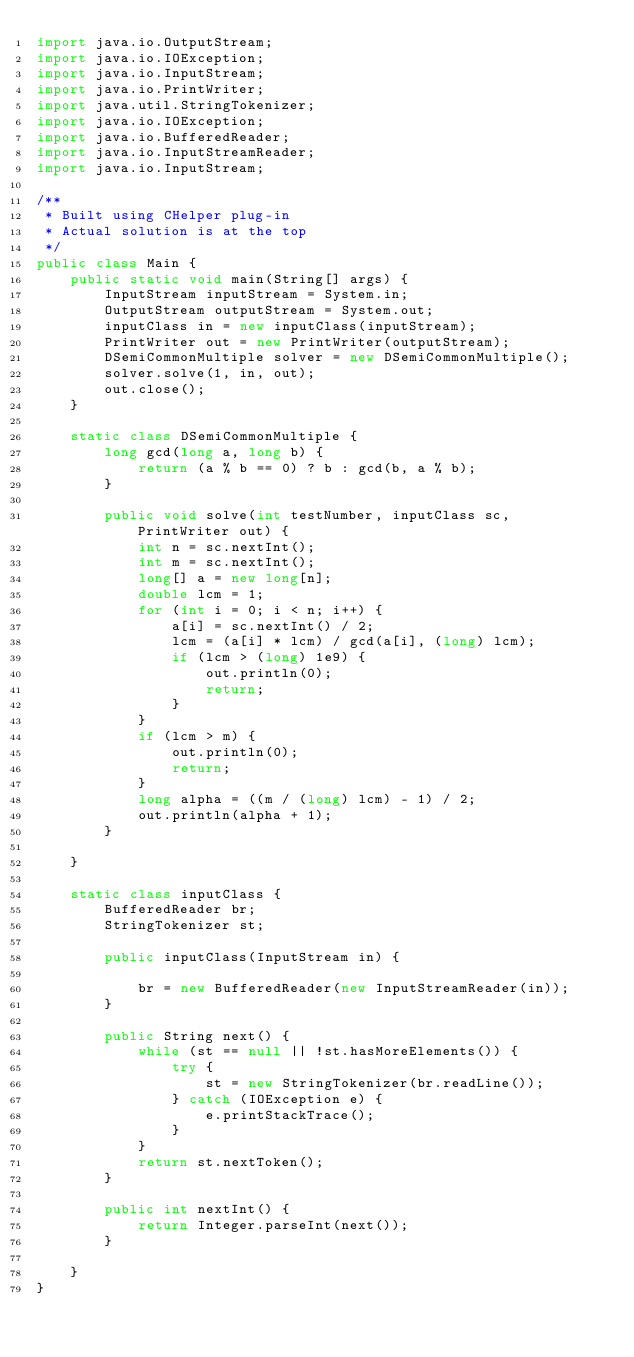<code> <loc_0><loc_0><loc_500><loc_500><_Java_>import java.io.OutputStream;
import java.io.IOException;
import java.io.InputStream;
import java.io.PrintWriter;
import java.util.StringTokenizer;
import java.io.IOException;
import java.io.BufferedReader;
import java.io.InputStreamReader;
import java.io.InputStream;

/**
 * Built using CHelper plug-in
 * Actual solution is at the top
 */
public class Main {
    public static void main(String[] args) {
        InputStream inputStream = System.in;
        OutputStream outputStream = System.out;
        inputClass in = new inputClass(inputStream);
        PrintWriter out = new PrintWriter(outputStream);
        DSemiCommonMultiple solver = new DSemiCommonMultiple();
        solver.solve(1, in, out);
        out.close();
    }

    static class DSemiCommonMultiple {
        long gcd(long a, long b) {
            return (a % b == 0) ? b : gcd(b, a % b);
        }

        public void solve(int testNumber, inputClass sc, PrintWriter out) {
            int n = sc.nextInt();
            int m = sc.nextInt();
            long[] a = new long[n];
            double lcm = 1;
            for (int i = 0; i < n; i++) {
                a[i] = sc.nextInt() / 2;
                lcm = (a[i] * lcm) / gcd(a[i], (long) lcm);
                if (lcm > (long) 1e9) {
                    out.println(0);
                    return;
                }
            }
            if (lcm > m) {
                out.println(0);
                return;
            }
            long alpha = ((m / (long) lcm) - 1) / 2;
            out.println(alpha + 1);
        }

    }

    static class inputClass {
        BufferedReader br;
        StringTokenizer st;

        public inputClass(InputStream in) {

            br = new BufferedReader(new InputStreamReader(in));
        }

        public String next() {
            while (st == null || !st.hasMoreElements()) {
                try {
                    st = new StringTokenizer(br.readLine());
                } catch (IOException e) {
                    e.printStackTrace();
                }
            }
            return st.nextToken();
        }

        public int nextInt() {
            return Integer.parseInt(next());
        }

    }
}

</code> 